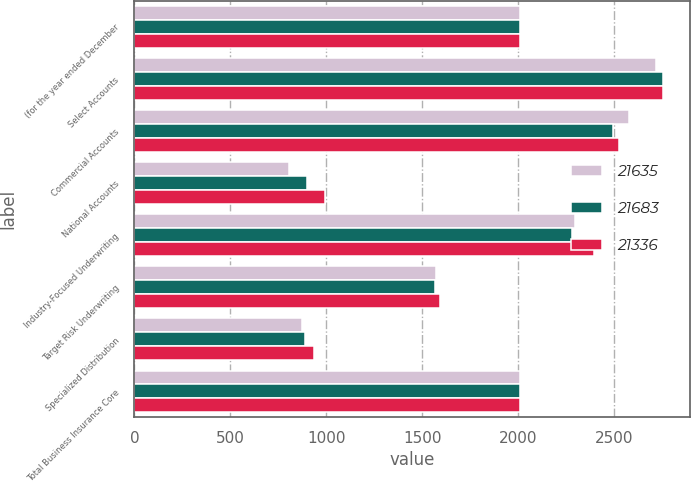Convert chart. <chart><loc_0><loc_0><loc_500><loc_500><stacked_bar_chart><ecel><fcel>(for the year ended December<fcel>Select Accounts<fcel>Commercial Accounts<fcel>National Accounts<fcel>Industry-Focused Underwriting<fcel>Target Risk Underwriting<fcel>Specialized Distribution<fcel>Total Business Insurance Core<nl><fcel>21635<fcel>2010<fcel>2718<fcel>2576<fcel>806<fcel>2299<fcel>1573<fcel>872<fcel>2009<nl><fcel>21683<fcel>2009<fcel>2756<fcel>2493<fcel>902<fcel>2279<fcel>1568<fcel>889<fcel>2009<nl><fcel>21336<fcel>2008<fcel>2756<fcel>2524<fcel>996<fcel>2396<fcel>1593<fcel>939<fcel>2009<nl></chart> 